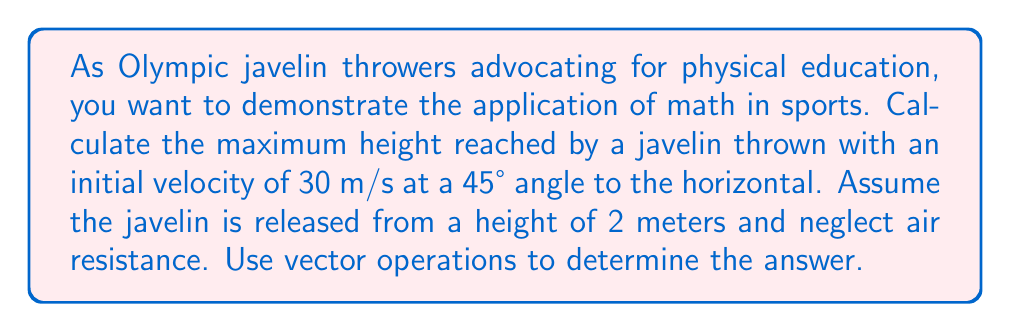Can you solve this math problem? Let's approach this step-by-step using vector operations:

1) First, we need to break down the initial velocity vector into its horizontal and vertical components:

   $v_x = v \cos \theta = 30 \cos 45° = 30 \cdot \frac{\sqrt{2}}{2} \approx 21.21$ m/s
   $v_y = v \sin \theta = 30 \sin 45° = 30 \cdot \frac{\sqrt{2}}{2} \approx 21.21$ m/s

2) The time to reach maximum height is when the vertical velocity becomes zero:

   $v_y(t) = v_y - gt$
   $0 = 21.21 - 9.8t$
   $t = \frac{21.21}{9.8} \approx 2.16$ seconds

3) Now we can calculate the maximum height using the equation:

   $y(t) = y_0 + v_yt - \frac{1}{2}gt^2$

   Where $y_0$ is the initial height (2 meters).

4) Substituting our values:

   $y_{max} = 2 + 21.21(2.16) - \frac{1}{2}(9.8)(2.16)^2$
   $y_{max} = 2 + 45.81 - 22.90$
   $y_{max} = 24.91$ meters

5) To get the maximum height reached by the javelin, we need to subtract the initial height:

   $h_{max} = y_{max} - y_0 = 24.91 - 2 = 22.91$ meters
Answer: 22.91 m 